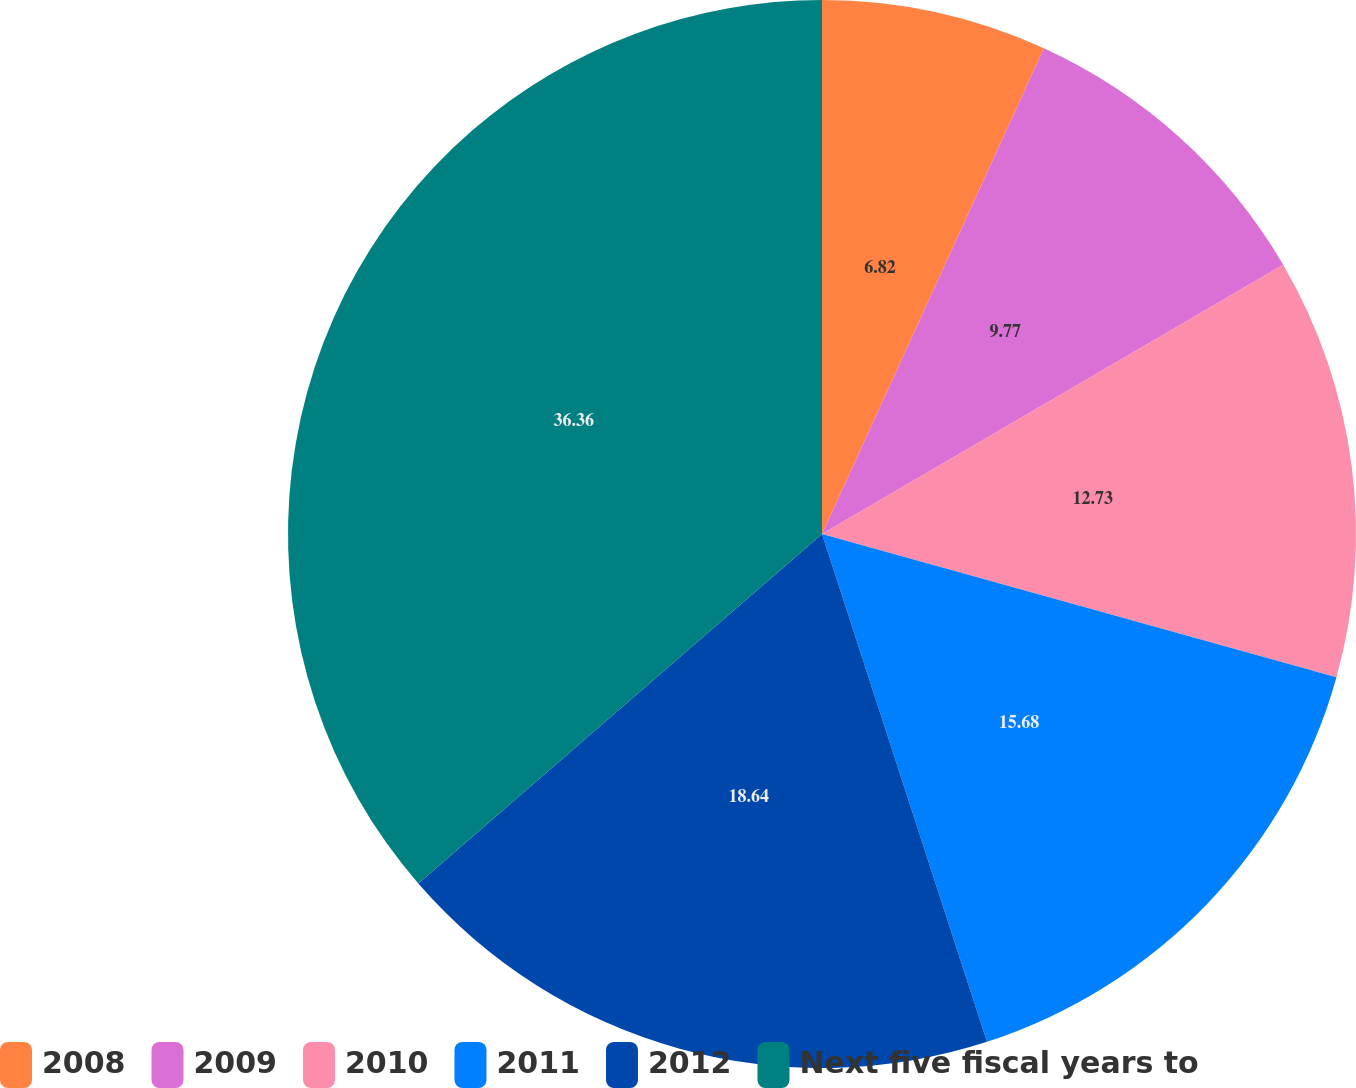<chart> <loc_0><loc_0><loc_500><loc_500><pie_chart><fcel>2008<fcel>2009<fcel>2010<fcel>2011<fcel>2012<fcel>Next five fiscal years to<nl><fcel>6.82%<fcel>9.77%<fcel>12.73%<fcel>15.68%<fcel>18.64%<fcel>36.36%<nl></chart> 